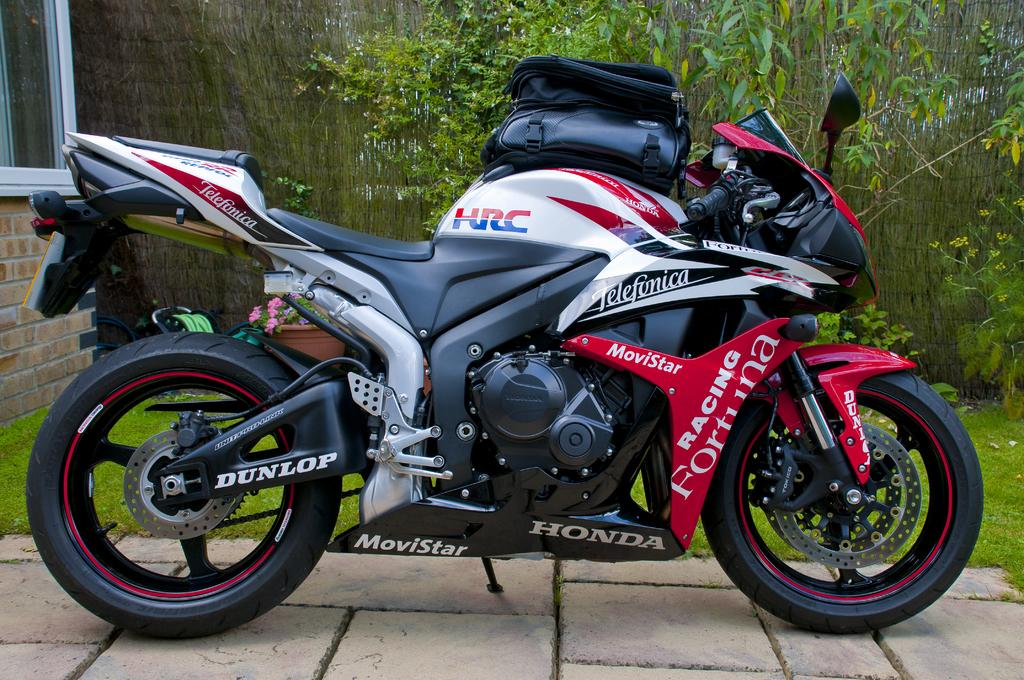What is on the bike in the image? There is a bag on a bike in the image. What can be seen in the background of the image? There are trees and a building in the background of the image. Can you describe an object in the image that contains plants? There is a flower pot in the image that contains plants. What type of vegetation is present in the image? There are plants visible in the image. What type of cherries are hanging from the trees in the image? There are no cherries present in the image; only trees and a building can be seen in the background. 